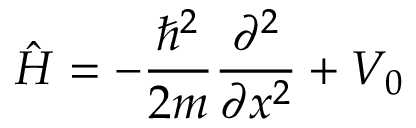Convert formula to latex. <formula><loc_0><loc_0><loc_500><loc_500>{ \hat { H } } = - { \frac { \hbar { ^ } { 2 } } { 2 m } } { \frac { \partial ^ { 2 } } { \partial x ^ { 2 } } } + V _ { 0 }</formula> 